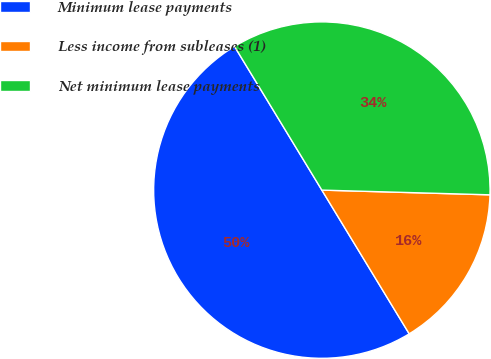Convert chart. <chart><loc_0><loc_0><loc_500><loc_500><pie_chart><fcel>Minimum lease payments<fcel>Less income from subleases (1)<fcel>Net minimum lease payments<nl><fcel>50.0%<fcel>15.86%<fcel>34.14%<nl></chart> 